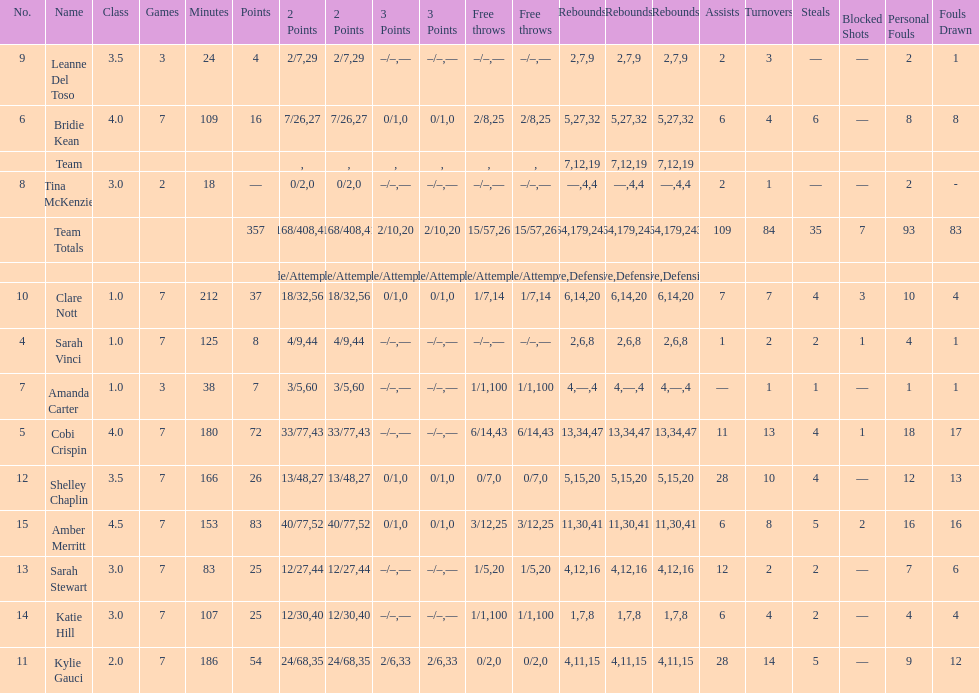Who is the first person on the list to play less than 20 minutes? Tina McKenzie. Could you parse the entire table as a dict? {'header': ['No.', 'Name', 'Class', 'Games', 'Minutes', 'Points', '2 Points', '2 Points', '3 Points', '3 Points', 'Free throws', 'Free throws', 'Rebounds', 'Rebounds', 'Rebounds', 'Assists', 'Turnovers', 'Steals', 'Blocked Shots', 'Personal Fouls', 'Fouls Drawn'], 'rows': [['9', 'Leanne Del Toso', '3.5', '3', '24', '4', '2/7', '29', '–/–', '—', '–/–', '—', '2', '7', '9', '2', '3', '—', '—', '2', '1'], ['6', 'Bridie Kean', '4.0', '7', '109', '16', '7/26', '27', '0/1', '0', '2/8', '25', '5', '27', '32', '6', '4', '6', '—', '8', '8'], ['', 'Team', '', '', '', '', '', '', '', '', '', '', '7', '12', '19', '', '', '', '', '', ''], ['8', 'Tina McKenzie', '3.0', '2', '18', '—', '0/2', '0', '–/–', '—', '–/–', '—', '—', '4', '4', '2', '1', '—', '—', '2', '-'], ['', 'Team Totals', '', '', '', '357', '168/408', '41', '2/10', '20', '15/57', '26', '64', '179', '243', '109', '84', '35', '7', '93', '83'], ['', '', '', '', '', '', 'Made/Attempts', '%', 'Made/Attempts', '%', 'Made/Attempts', '%', 'Offensive', 'Defensive', 'Total', '', '', '', '', '', ''], ['10', 'Clare Nott', '1.0', '7', '212', '37', '18/32', '56', '0/1', '0', '1/7', '14', '6', '14', '20', '7', '7', '4', '3', '10', '4'], ['4', 'Sarah Vinci', '1.0', '7', '125', '8', '4/9', '44', '–/–', '—', '–/–', '—', '2', '6', '8', '1', '2', '2', '1', '4', '1'], ['7', 'Amanda Carter', '1.0', '3', '38', '7', '3/5', '60', '–/–', '—', '1/1', '100', '4', '—', '4', '—', '1', '1', '—', '1', '1'], ['5', 'Cobi Crispin', '4.0', '7', '180', '72', '33/77', '43', '–/–', '—', '6/14', '43', '13', '34', '47', '11', '13', '4', '1', '18', '17'], ['12', 'Shelley Chaplin', '3.5', '7', '166', '26', '13/48', '27', '0/1', '0', '0/7', '0', '5', '15', '20', '28', '10', '4', '—', '12', '13'], ['15', 'Amber Merritt', '4.5', '7', '153', '83', '40/77', '52', '0/1', '0', '3/12', '25', '11', '30', '41', '6', '8', '5', '2', '16', '16'], ['13', 'Sarah Stewart', '3.0', '7', '83', '25', '12/27', '44', '–/–', '—', '1/5', '20', '4', '12', '16', '12', '2', '2', '—', '7', '6'], ['14', 'Katie Hill', '3.0', '7', '107', '25', '12/30', '40', '–/–', '—', '1/1', '100', '1', '7', '8', '6', '4', '2', '—', '4', '4'], ['11', 'Kylie Gauci', '2.0', '7', '186', '54', '24/68', '35', '2/6', '33', '0/2', '0', '4', '11', '15', '28', '14', '5', '—', '9', '12']]} 